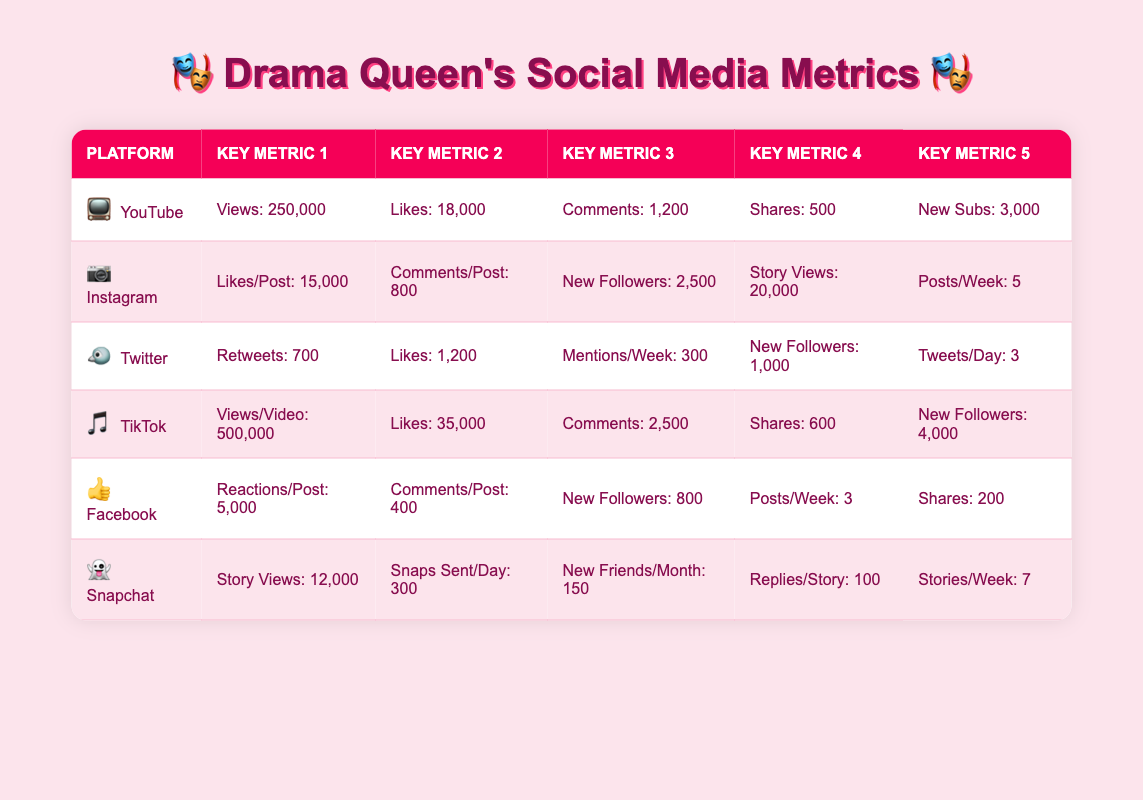What platform has the highest average views? By comparing the average views across all platforms, YouTube has 250,000 views and TikTok has 500,000 views. Since 500,000 is greater than 250,000, TikTok has the highest average views.
Answer: TikTok What is the total followers growth from Instagram and TikTok combined? Instagram shows a followers growth of 2,500, while TikTok has 4,000. Adding these together (2,500 + 4,000) gives a total of 6,500 for the two platforms combined.
Answer: 6,500 Is the average number of likes on TikTok higher than on YouTube? TikTok has an average of 35,000 likes, while YouTube has 18,000 likes. Comparing these values, 35,000 is greater than 18,000.
Answer: Yes How many new subscribers does YouTube gain compared to new friends added per month on Snapchat? YouTube gains 3,000 new subscribers while Snapchat adds 150 new friends per month. The difference is (3,000 - 150) = 2,850. So, YouTube gains 2,850 more new subscribers than Snapchat.
Answer: 2,850 Which platform has the lowest average comments per post between Instagram and Facebook? Instagram has an average of 800 comments per post, while Facebook has 400 comments per post. Comparing the two, 400 is less than 800, indicating Facebook has lower engagement.
Answer: Facebook What is the average number of likes per post on Instagram and Facebook? Instagram has 15,000 likes per post and Facebook has 5,000. To find the average, we sum these values (15,000 + 5,000) = 20,000 and divide by 2, resulting in an average of 10,000 likes per post across both platforms.
Answer: 10,000 Is the average reactions per post on Facebook greater than the average comments per post on Snapchat? Facebook has 5,000 reactions per post while Snapchat does not have a listed average, only total replies. However, we know from Snapchat’s data that there are 100 replies per story, making this an invalid comparison.
Answer: No What is the total number of posts per week across both Instagram and Facebook? On Instagram, there are 5 posts per week, and on Facebook, there are 3 posts. Adding these gives (5 + 3) = 8 posts per week across both platforms.
Answer: 8 